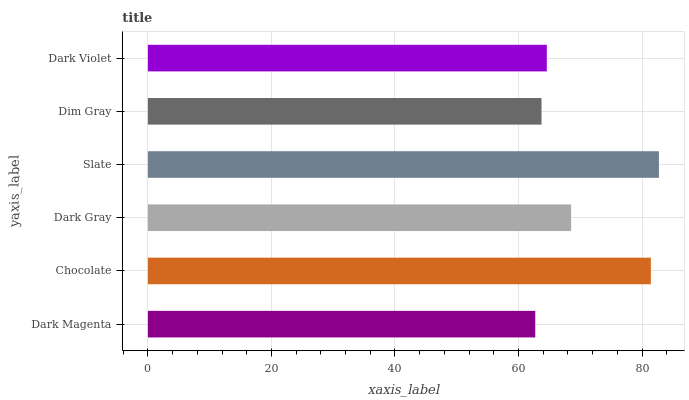Is Dark Magenta the minimum?
Answer yes or no. Yes. Is Slate the maximum?
Answer yes or no. Yes. Is Chocolate the minimum?
Answer yes or no. No. Is Chocolate the maximum?
Answer yes or no. No. Is Chocolate greater than Dark Magenta?
Answer yes or no. Yes. Is Dark Magenta less than Chocolate?
Answer yes or no. Yes. Is Dark Magenta greater than Chocolate?
Answer yes or no. No. Is Chocolate less than Dark Magenta?
Answer yes or no. No. Is Dark Gray the high median?
Answer yes or no. Yes. Is Dark Violet the low median?
Answer yes or no. Yes. Is Slate the high median?
Answer yes or no. No. Is Chocolate the low median?
Answer yes or no. No. 